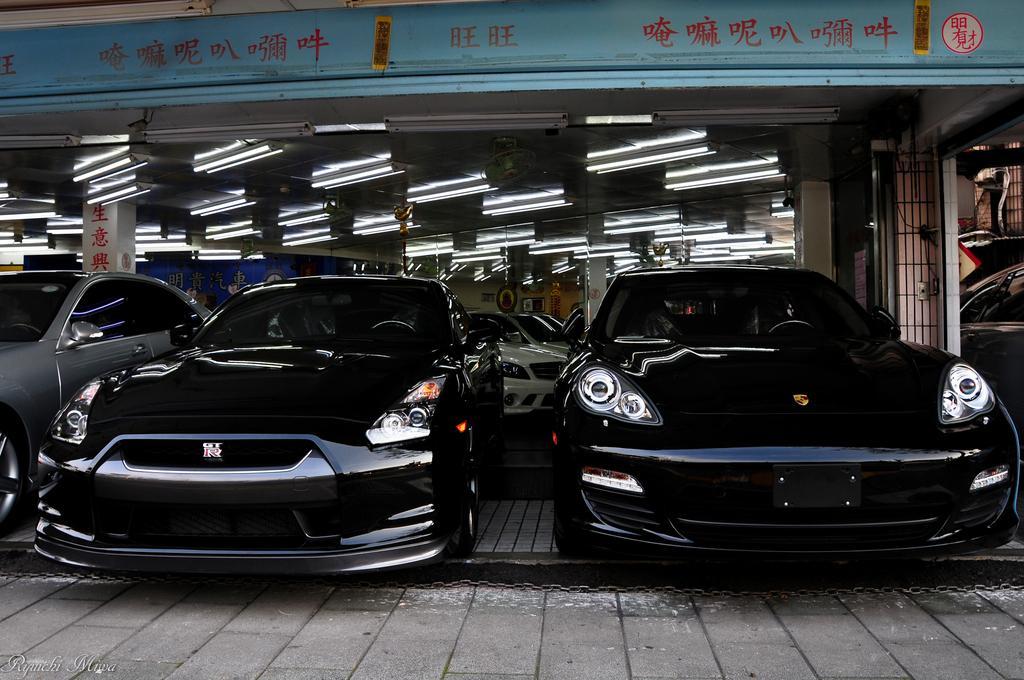Could you give a brief overview of what you see in this image? In this picture we can see there are some vehicles parked. At the top there are lights. Behind the vehicles there are pillars, boards and the wall. On the right side of the vehicles there are iron grilles 